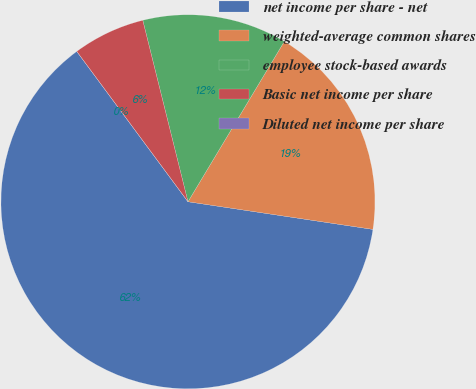<chart> <loc_0><loc_0><loc_500><loc_500><pie_chart><fcel>net income per share - net<fcel>weighted-average common shares<fcel>employee stock-based awards<fcel>Basic net income per share<fcel>Diluted net income per share<nl><fcel>62.5%<fcel>18.75%<fcel>12.5%<fcel>6.25%<fcel>0.0%<nl></chart> 